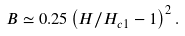<formula> <loc_0><loc_0><loc_500><loc_500>B \simeq 0 . 2 5 \left ( H / H _ { c 1 } - 1 \right ) ^ { 2 } . \,</formula> 